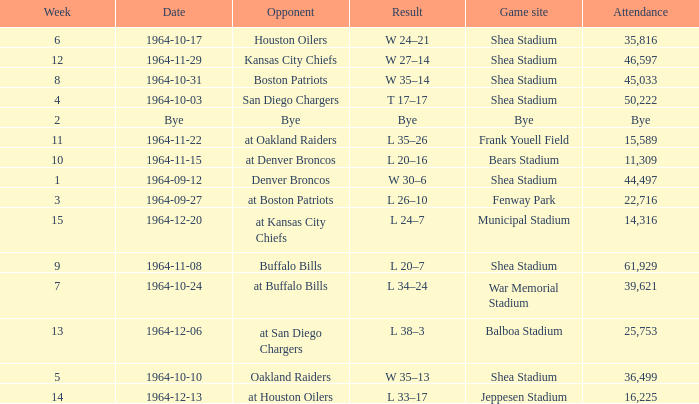What's the Result for week 15? L 24–7. 